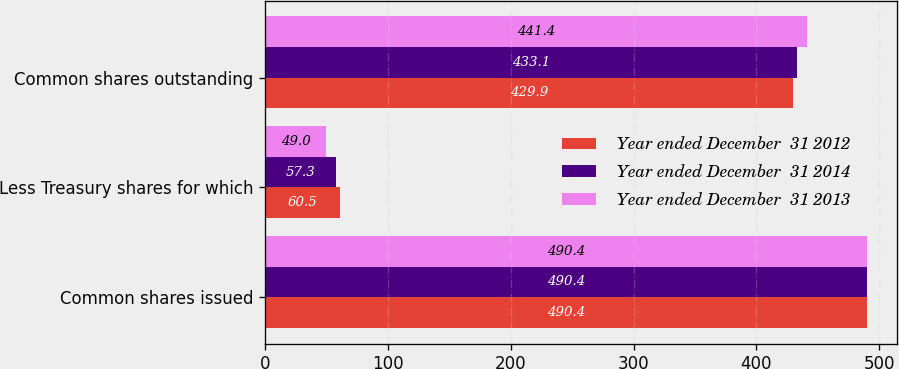Convert chart. <chart><loc_0><loc_0><loc_500><loc_500><stacked_bar_chart><ecel><fcel>Common shares issued<fcel>Less Treasury shares for which<fcel>Common shares outstanding<nl><fcel>Year ended December  31 2012<fcel>490.4<fcel>60.5<fcel>429.9<nl><fcel>Year ended December  31 2014<fcel>490.4<fcel>57.3<fcel>433.1<nl><fcel>Year ended December  31 2013<fcel>490.4<fcel>49<fcel>441.4<nl></chart> 